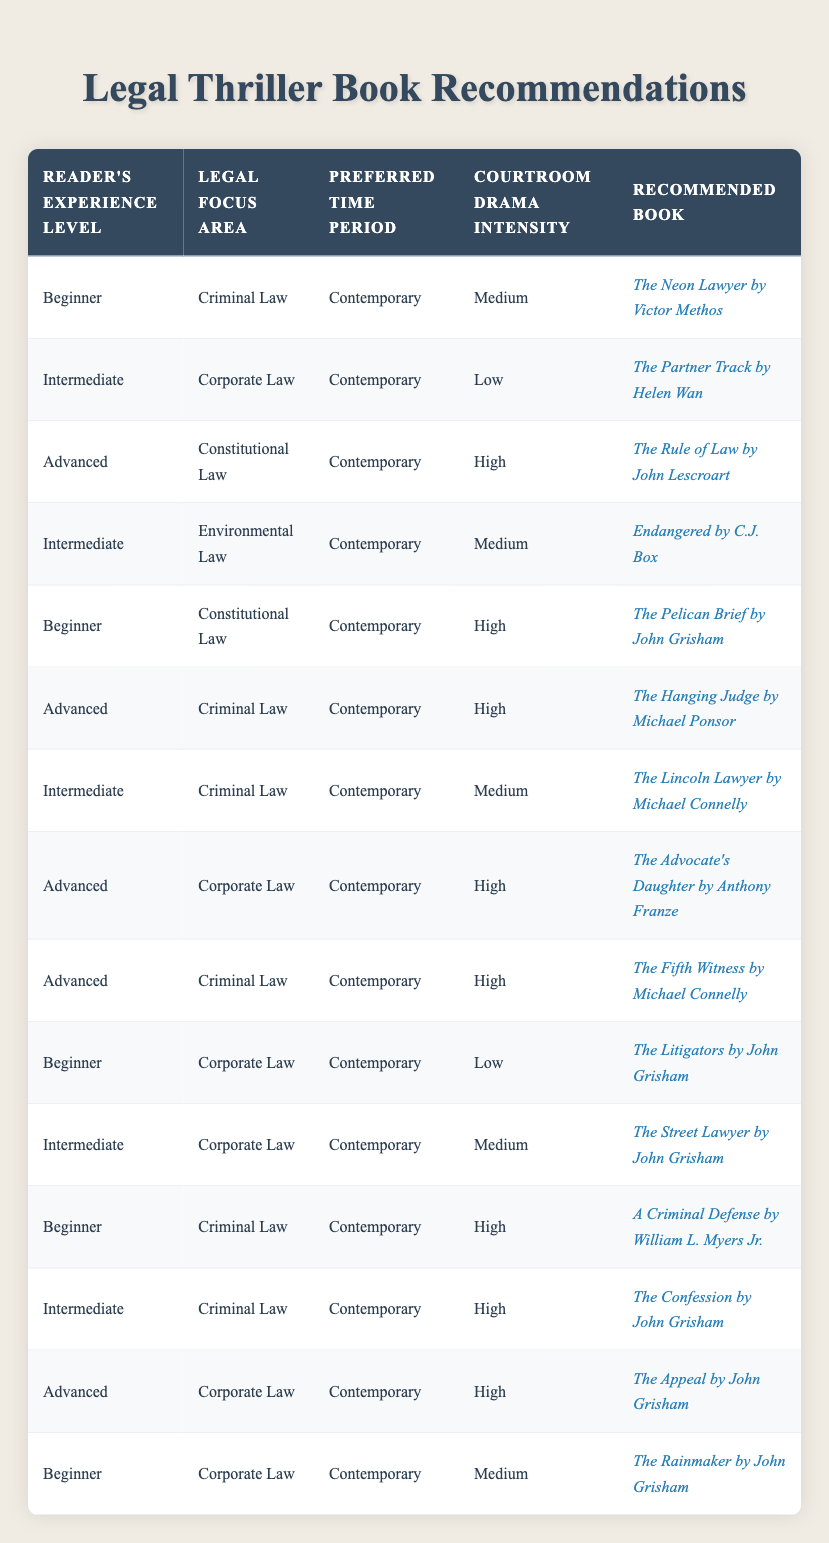What book is recommended for a Beginner focusing on Criminal Law with Medium courtroom drama intensity? For a Beginner, the row corresponding to Beginner, Criminal Law, and Medium courtroom drama intensity shows that the recommended book is "The Neon Lawyer by Victor Methos."
Answer: The Neon Lawyer by Victor Methos Is there a book recommended for Intermediate readers interested in Corporate Law and a Low intensity level? By checking the table, there is indeed a recommendation for Intermediate readers focused on Corporate Law with Low courtroom drama intensity. The book is "The Partner Track by Helen Wan."
Answer: Yes, The Partner Track by Helen Wan What is the recommended book for Advanced readers focusing on Constitutional Law with High courtroom drama intensity? In the table, for Advanced readers focusing on Constitutional Law and High intensity, the recommended book is "The Rule of Law by John Lescroart."
Answer: The Rule of Law by John Lescroart How many books are recommended for Beginner readers? Counting the rows in the table with "Beginner" as the value for Reader's Experience Level, there are 5 books recommended: "The Neon Lawyer," "The Pelican Brief," "A Criminal Defense," "The Litigators," and "The Rainmaker."
Answer: 5 Is "The Confession" recommended for Advanced readers in Criminal Law with High drama intensity? Looking at the table, "The Confession" is indeed recommended, but it’s for Intermediate readers focusing on Criminal Law with High intensity, not Advanced, thus the statement is false.
Answer: No Which legal focus area has the most recommended books for Intermediate readers? By reviewing the recommendations for Intermediate readers, "Corporate Law" appears twice ("The Partner Track" and "The Street Lawyer"), making it the legal focus area with the most recommendations.
Answer: Corporate Law What is the range of courtroom drama intensities recommended for Advanced readers? Advanced readers in the table have recommendations that show a range of courtroom drama intensities: Low (1), Medium (1), and High (3), indicating they can experience various intensity levels in their recommended books.
Answer: Low, Medium, High What is the recommended book for beginners focusing on Corporate Law with Medium intensity? The table shows that for Beginners interested in Corporate Law, the recommended book with Medium intensity is "The Rainmaker by John Grisham."
Answer: The Rainmaker by John Grisham 